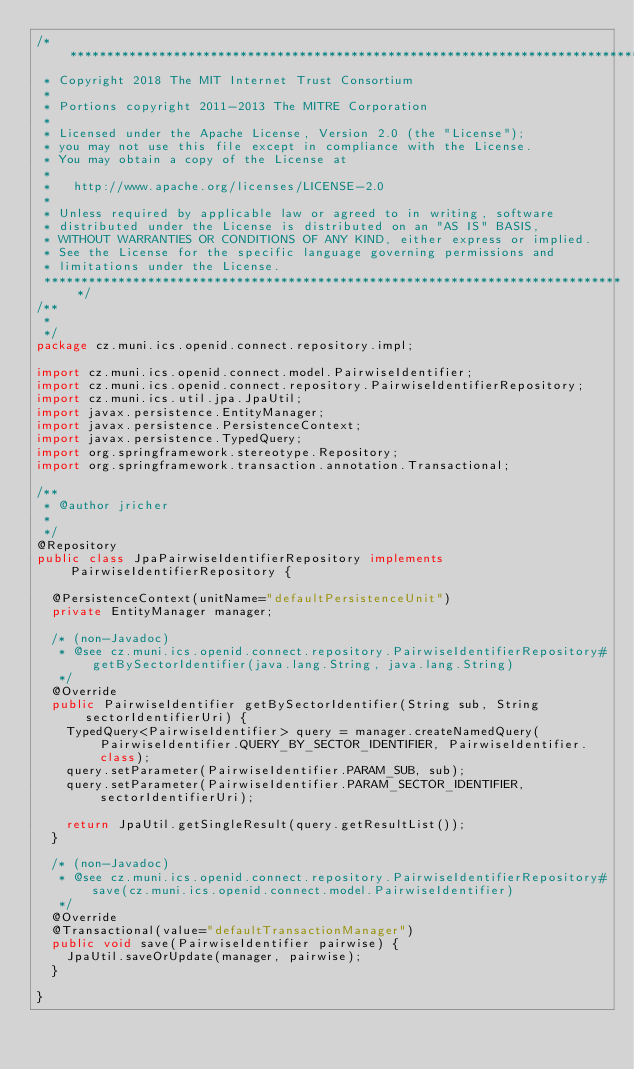<code> <loc_0><loc_0><loc_500><loc_500><_Java_>/*******************************************************************************
 * Copyright 2018 The MIT Internet Trust Consortium
 *
 * Portions copyright 2011-2013 The MITRE Corporation
 *
 * Licensed under the Apache License, Version 2.0 (the "License");
 * you may not use this file except in compliance with the License.
 * You may obtain a copy of the License at
 *
 *   http://www.apache.org/licenses/LICENSE-2.0
 *
 * Unless required by applicable law or agreed to in writing, software
 * distributed under the License is distributed on an "AS IS" BASIS,
 * WITHOUT WARRANTIES OR CONDITIONS OF ANY KIND, either express or implied.
 * See the License for the specific language governing permissions and
 * limitations under the License.
 *******************************************************************************/
/**
 *
 */
package cz.muni.ics.openid.connect.repository.impl;

import cz.muni.ics.openid.connect.model.PairwiseIdentifier;
import cz.muni.ics.openid.connect.repository.PairwiseIdentifierRepository;
import cz.muni.ics.util.jpa.JpaUtil;
import javax.persistence.EntityManager;
import javax.persistence.PersistenceContext;
import javax.persistence.TypedQuery;
import org.springframework.stereotype.Repository;
import org.springframework.transaction.annotation.Transactional;

/**
 * @author jricher
 *
 */
@Repository
public class JpaPairwiseIdentifierRepository implements PairwiseIdentifierRepository {

	@PersistenceContext(unitName="defaultPersistenceUnit")
	private EntityManager manager;

	/* (non-Javadoc)
	 * @see cz.muni.ics.openid.connect.repository.PairwiseIdentifierRepository#getBySectorIdentifier(java.lang.String, java.lang.String)
	 */
	@Override
	public PairwiseIdentifier getBySectorIdentifier(String sub, String sectorIdentifierUri) {
		TypedQuery<PairwiseIdentifier> query = manager.createNamedQuery(PairwiseIdentifier.QUERY_BY_SECTOR_IDENTIFIER, PairwiseIdentifier.class);
		query.setParameter(PairwiseIdentifier.PARAM_SUB, sub);
		query.setParameter(PairwiseIdentifier.PARAM_SECTOR_IDENTIFIER, sectorIdentifierUri);

		return JpaUtil.getSingleResult(query.getResultList());
	}

	/* (non-Javadoc)
	 * @see cz.muni.ics.openid.connect.repository.PairwiseIdentifierRepository#save(cz.muni.ics.openid.connect.model.PairwiseIdentifier)
	 */
	@Override
	@Transactional(value="defaultTransactionManager")
	public void save(PairwiseIdentifier pairwise) {
		JpaUtil.saveOrUpdate(manager, pairwise);
	}

}
</code> 